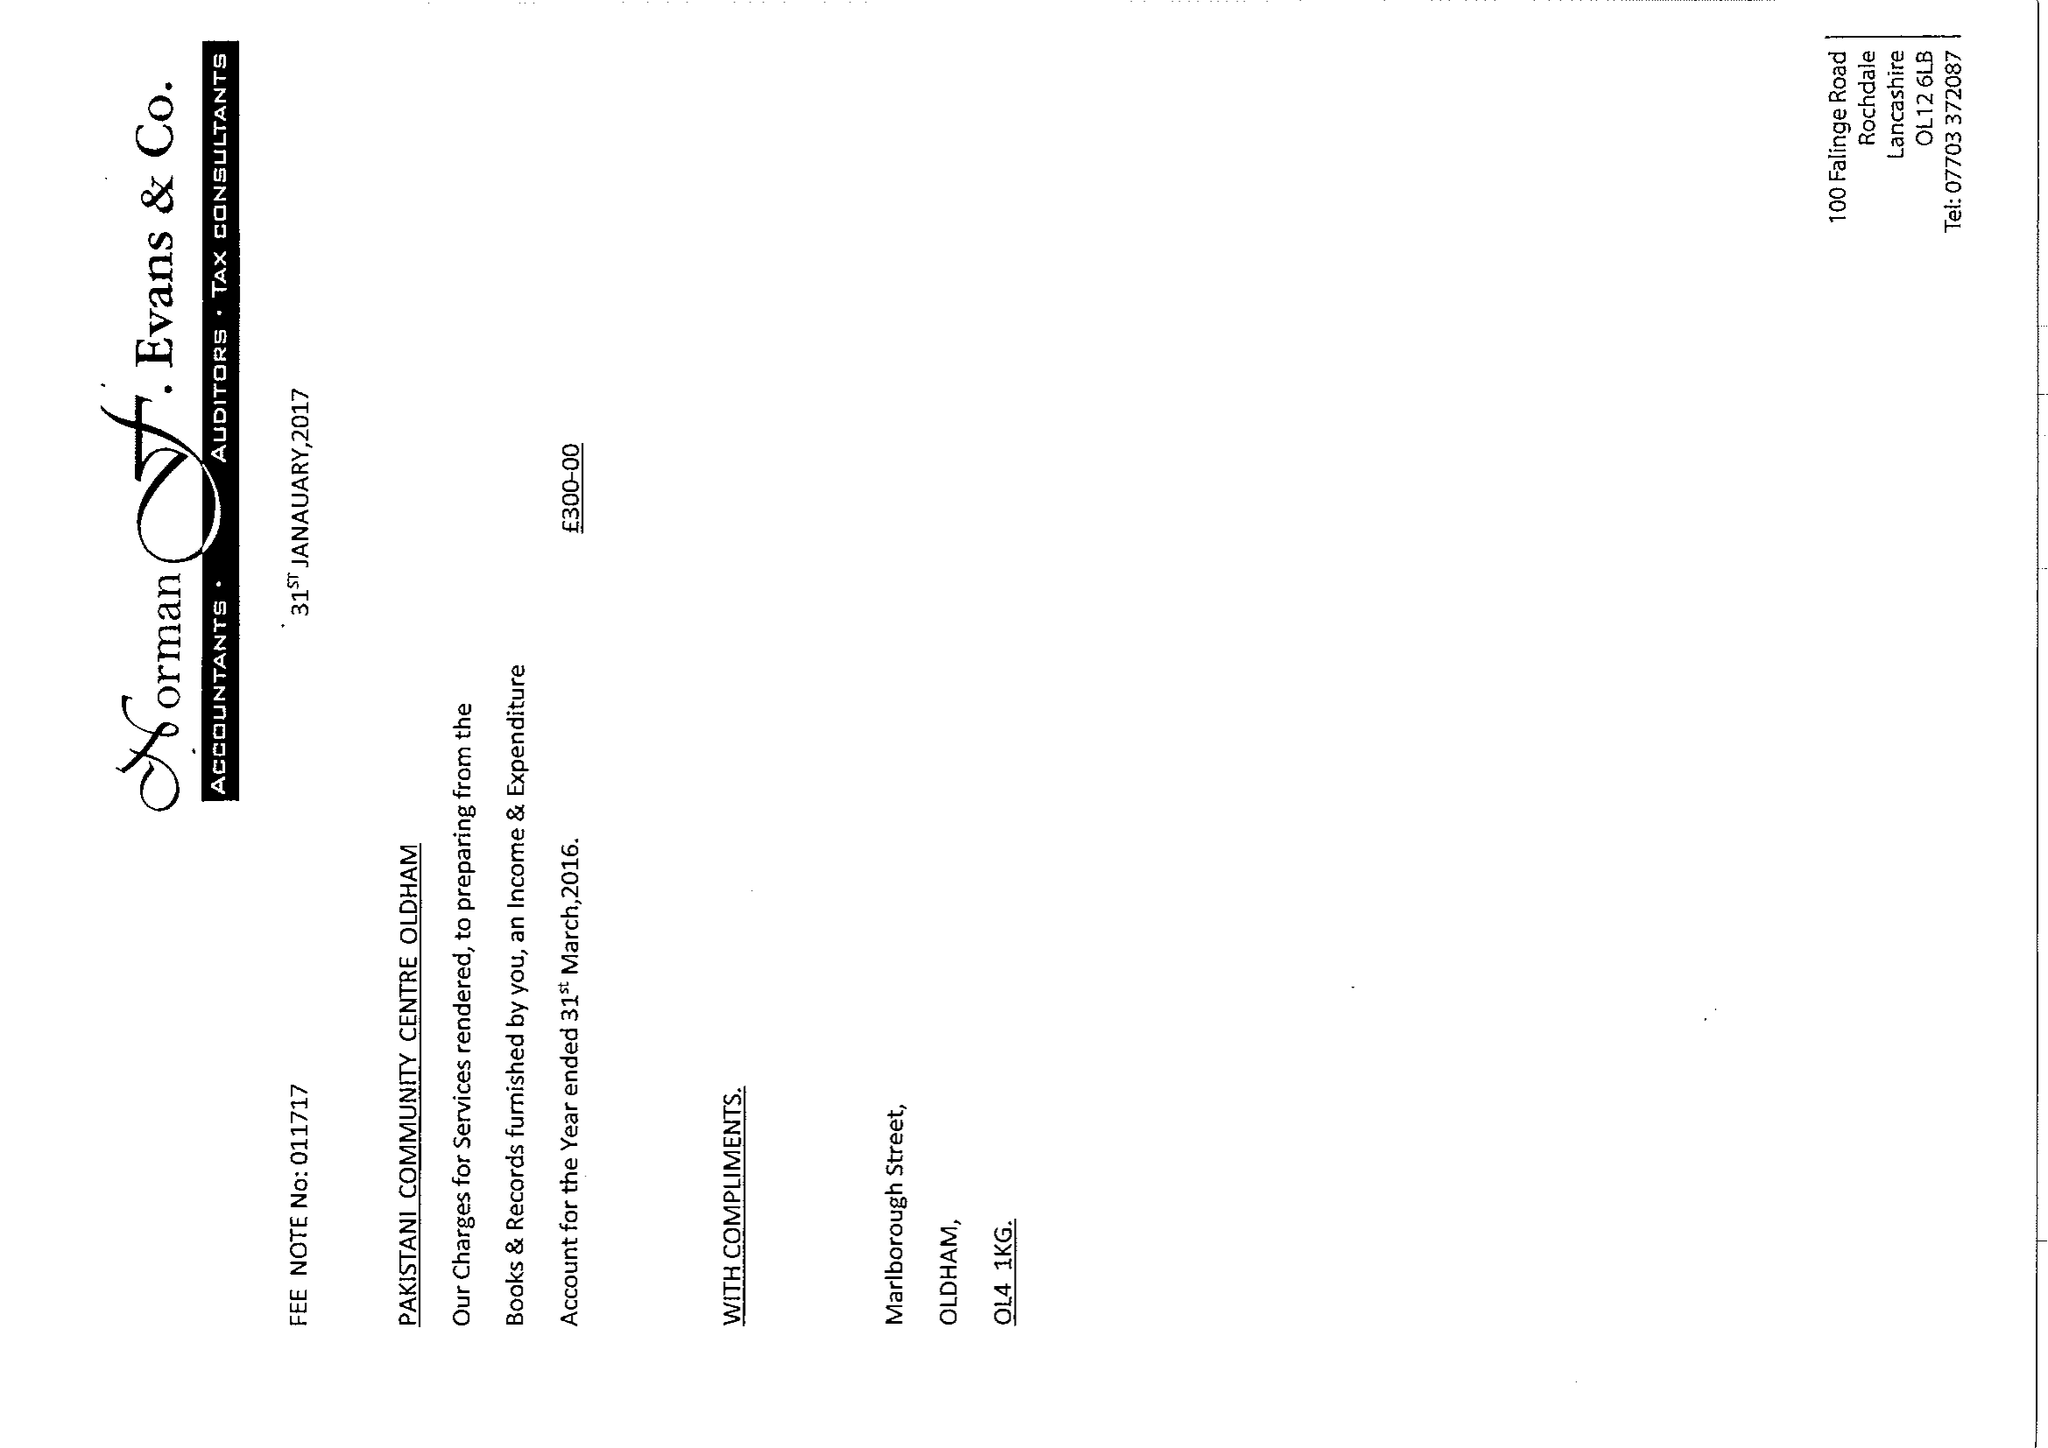What is the value for the report_date?
Answer the question using a single word or phrase. 2016-03-31 